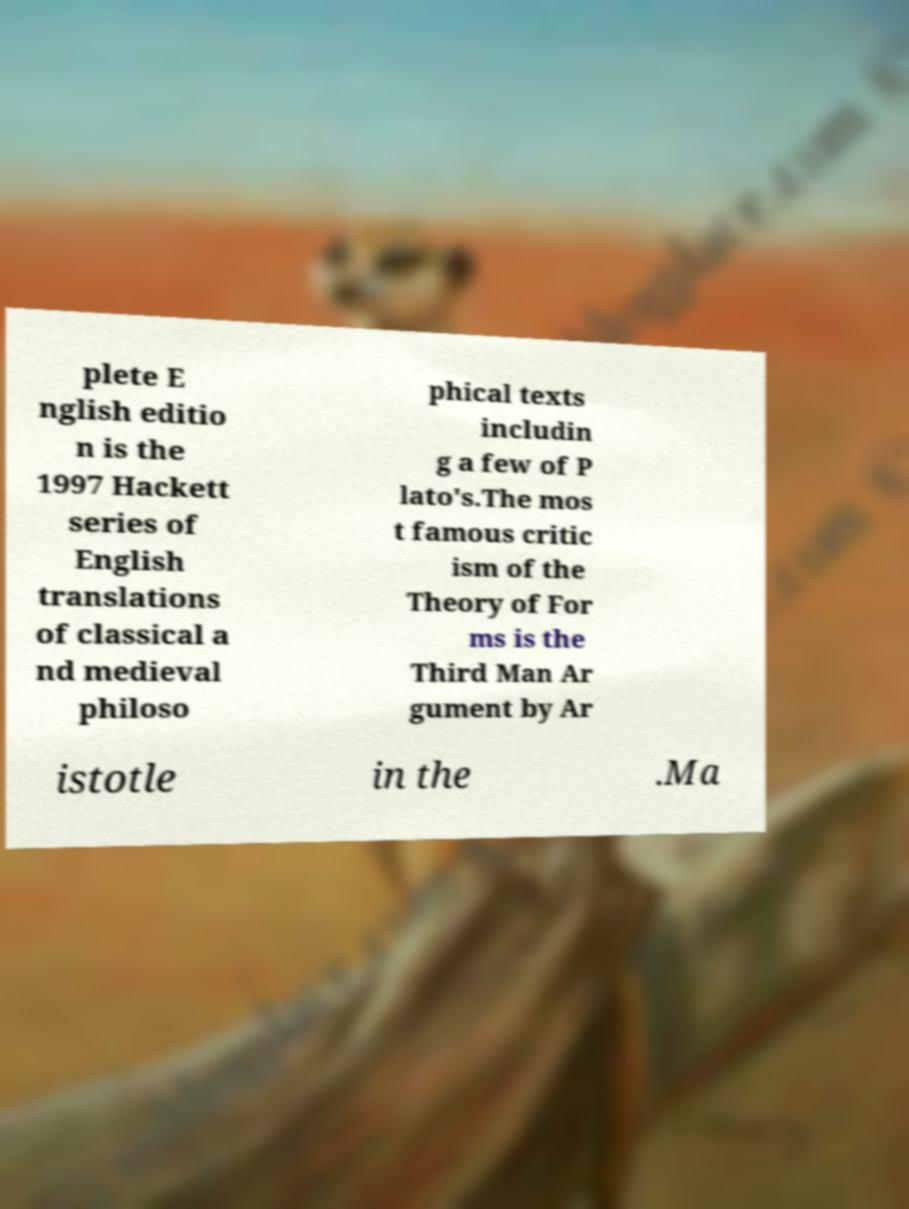Can you accurately transcribe the text from the provided image for me? plete E nglish editio n is the 1997 Hackett series of English translations of classical a nd medieval philoso phical texts includin g a few of P lato's.The mos t famous critic ism of the Theory of For ms is the Third Man Ar gument by Ar istotle in the .Ma 